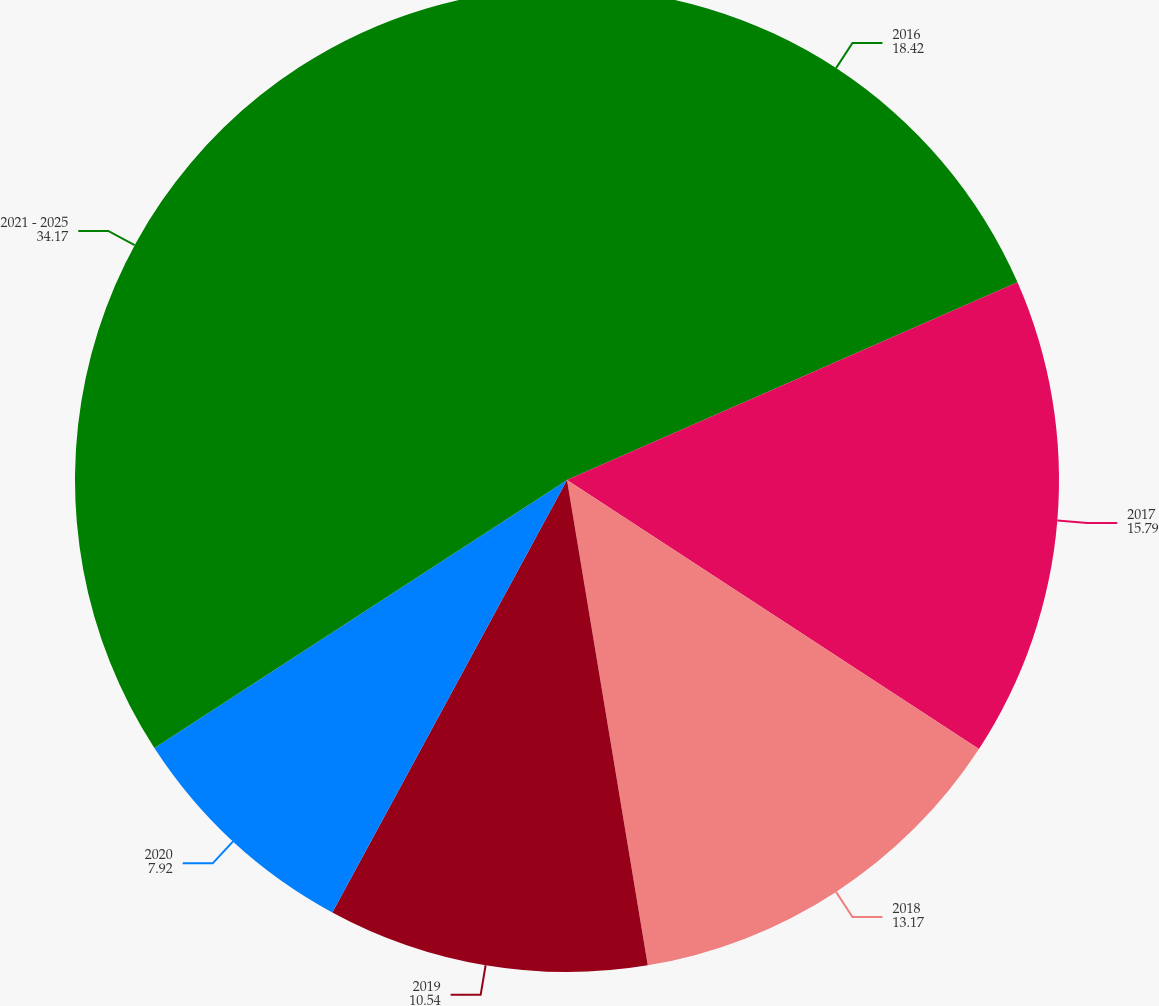Convert chart. <chart><loc_0><loc_0><loc_500><loc_500><pie_chart><fcel>2016<fcel>2017<fcel>2018<fcel>2019<fcel>2020<fcel>2021 - 2025<nl><fcel>18.42%<fcel>15.79%<fcel>13.17%<fcel>10.54%<fcel>7.92%<fcel>34.17%<nl></chart> 